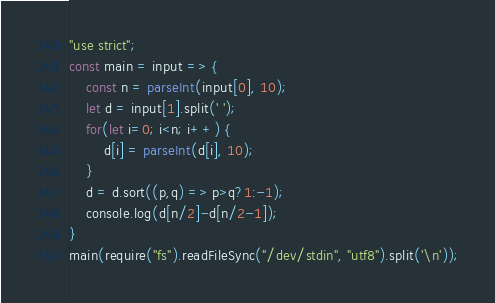<code> <loc_0><loc_0><loc_500><loc_500><_JavaScript_>"use strict";
const main = input => {
    const n = parseInt(input[0], 10);
    let d = input[1].split(' ');
    for(let i=0; i<n; i++) {
        d[i] = parseInt(d[i], 10);
    }
    d = d.sort((p,q) => p>q?1:-1);
    console.log(d[n/2]-d[n/2-1]);    
}
main(require("fs").readFileSync("/dev/stdin", "utf8").split('\n'));
</code> 